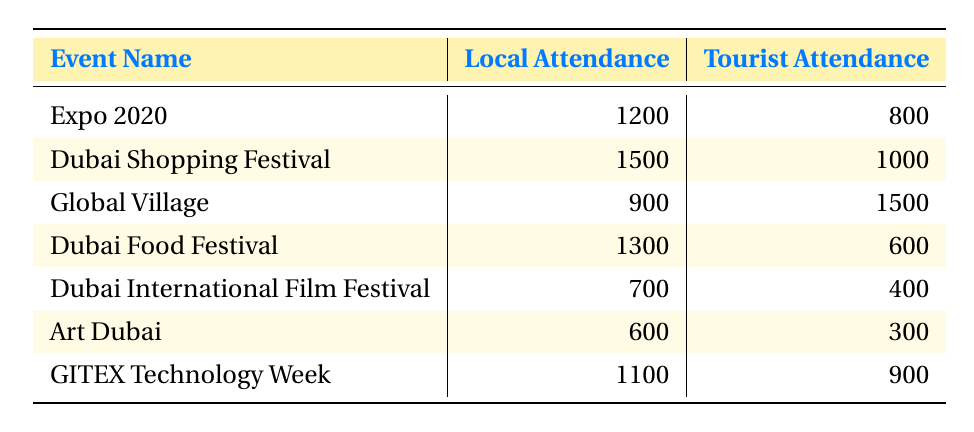What is the attendance for the Dubai Shopping Festival from locals? The table shows that the local attendance for the Dubai Shopping Festival is 1500.
Answer: 1500 Which event had the highest local attendance? By looking at the local attendance column, the highest attendance is for the Dubai Shopping Festival with 1500.
Answer: Dubai Shopping Festival How many more tourists attended the Global Village compared to locals? The Global Village had 1500 tourists and 900 locals. Subtracting these numbers: 1500 - 900 = 600.
Answer: 600 Are there more local attendees or tourist attendees for the Dubai Food Festival? The local attendance for the Dubai Food Festival is 1300 while the tourist attendance is 600. Since 1300 is greater than 600, there are more local attendees.
Answer: Yes What is the total local attendance across all events? To find the total local attendance, add the local attendance numbers: 1200 + 1500 + 900 + 1300 + 700 + 600 + 1100 = 6300.
Answer: 6300 Did the local attendance for the Expo 2020 exceed that of the Dubai International Film Festival? The local attendance for Expo 2020 is 1200 and for Dubai International Film Festival, it is 700. Since 1200 is greater than 700, the local attendance did exceed.
Answer: Yes What is the average tourist attendance across all events? To find the average tourist attendance, first sum the tourist attendance numbers: 800 + 1000 + 1500 + 600 + 400 + 300 + 900 = 4500. Then divide by the number of events, which is 7: 4500 / 7 = approximately 642.86.
Answer: 642.86 For which event did tourists have the minimum attendance? Looking at the tourist attendance column, the Dubai International Film Festival shows the lowest attendance with 400 tourists.
Answer: Dubai International Film Festival How does the local attendance for GITEX Technology Week compare to that of the Art Dubai? GITEX Technology Week had 1100 local attendees while Art Dubai had 600. Comparing these two numbers, 1100 is greater than 600. So, GITEX had more local attendance than Art Dubai.
Answer: Yes 